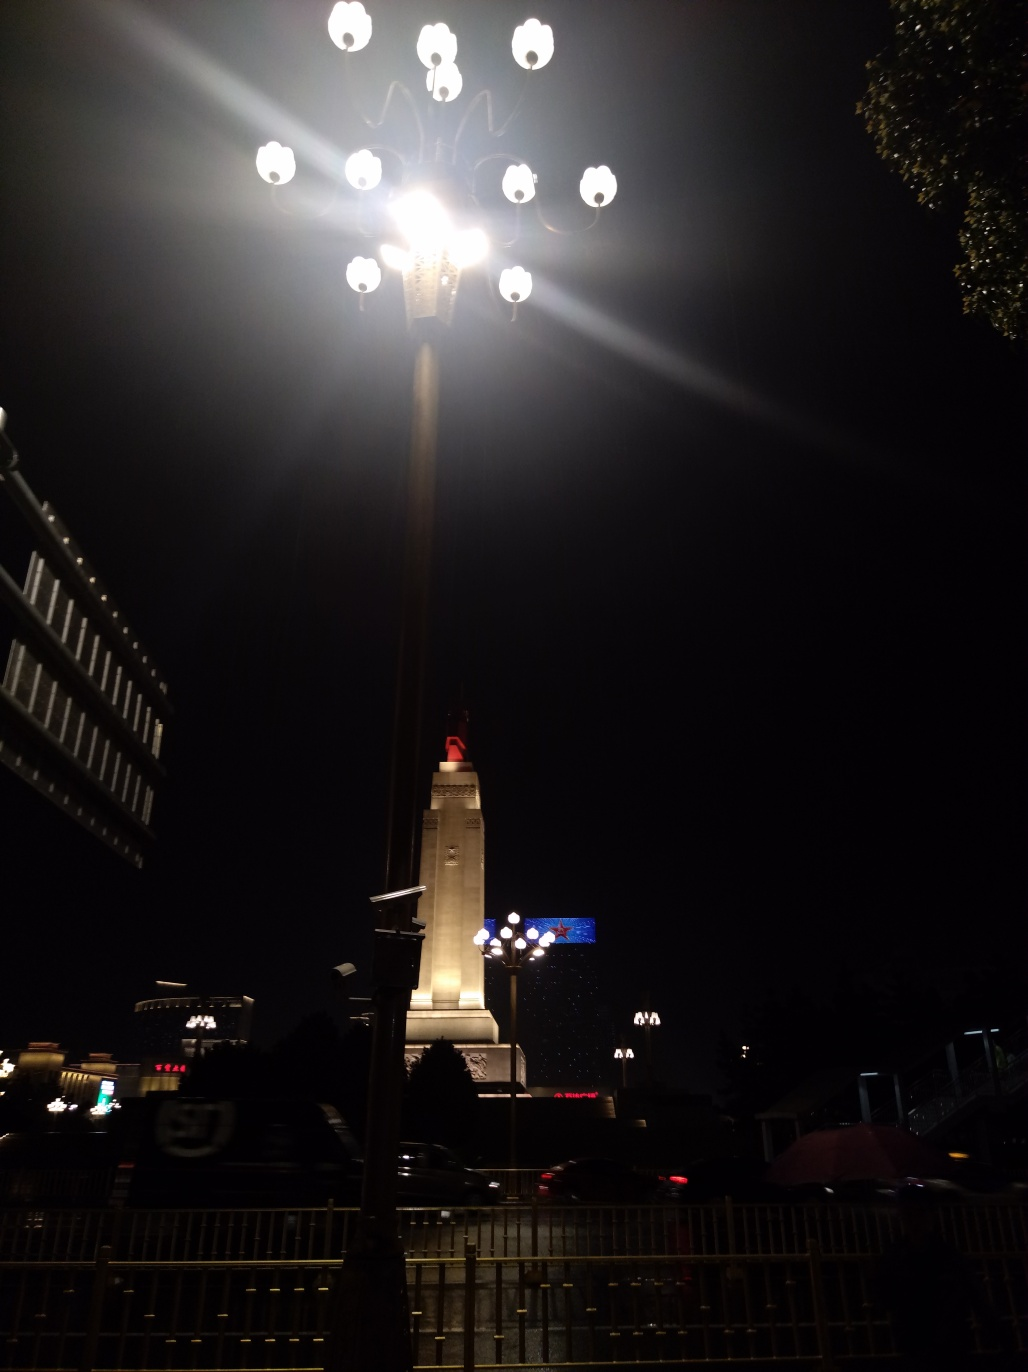Can you infer anything about the location or occasion based on the contents of the image? The image presents an urban environment, likely a city square or a similar public space, often found at the heart of a city. The specific monument and the flags suggest the location might hold historical significance and is likely to be of symbolic importance. The lighting and the structure of the monument convey a formal atmosphere, potentially signaling an important landmark in the vicinity. 